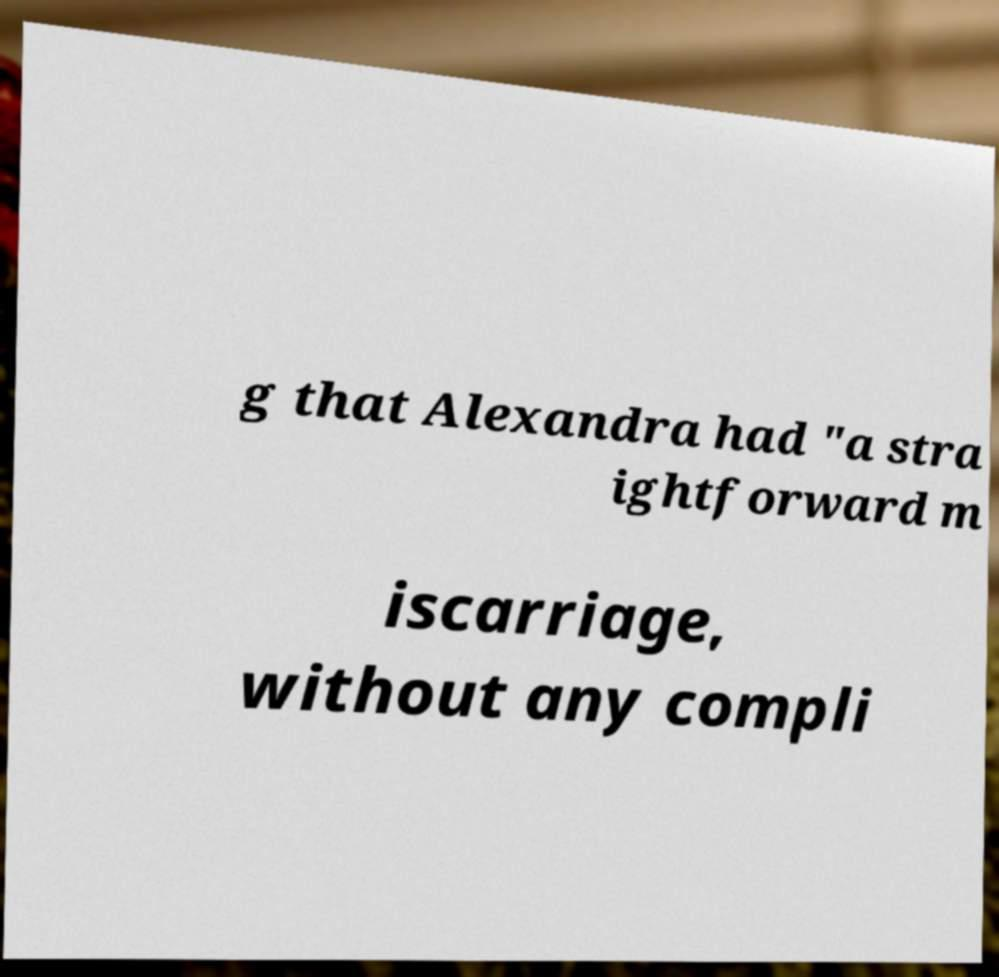Please identify and transcribe the text found in this image. g that Alexandra had "a stra ightforward m iscarriage, without any compli 